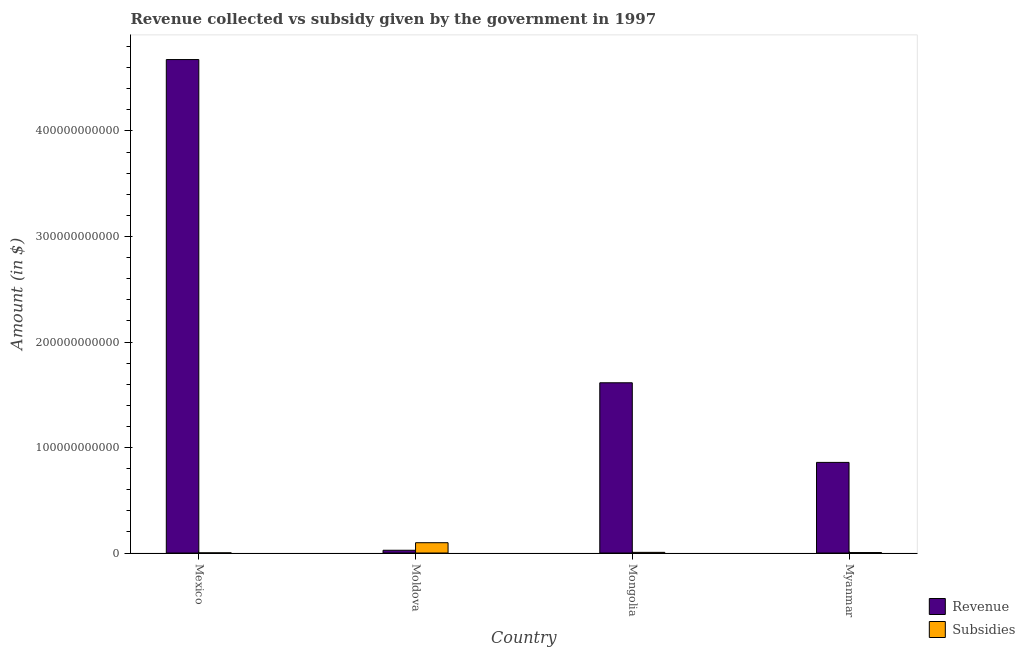How many different coloured bars are there?
Keep it short and to the point. 2. Are the number of bars per tick equal to the number of legend labels?
Ensure brevity in your answer.  Yes. Are the number of bars on each tick of the X-axis equal?
Your answer should be very brief. Yes. How many bars are there on the 2nd tick from the right?
Your response must be concise. 2. What is the label of the 1st group of bars from the left?
Give a very brief answer. Mexico. In how many cases, is the number of bars for a given country not equal to the number of legend labels?
Provide a short and direct response. 0. What is the amount of subsidies given in Mexico?
Keep it short and to the point. 1.33e+08. Across all countries, what is the maximum amount of subsidies given?
Provide a short and direct response. 9.78e+09. Across all countries, what is the minimum amount of revenue collected?
Your answer should be compact. 2.62e+09. In which country was the amount of subsidies given maximum?
Your response must be concise. Moldova. What is the total amount of revenue collected in the graph?
Make the answer very short. 7.18e+11. What is the difference between the amount of revenue collected in Mongolia and that in Myanmar?
Keep it short and to the point. 7.55e+1. What is the difference between the amount of subsidies given in Mexico and the amount of revenue collected in Mongolia?
Provide a short and direct response. -1.61e+11. What is the average amount of revenue collected per country?
Offer a terse response. 1.79e+11. What is the difference between the amount of subsidies given and amount of revenue collected in Mongolia?
Offer a terse response. -1.61e+11. In how many countries, is the amount of revenue collected greater than 360000000000 $?
Provide a succinct answer. 1. What is the ratio of the amount of revenue collected in Mexico to that in Myanmar?
Keep it short and to the point. 5.45. Is the amount of subsidies given in Moldova less than that in Myanmar?
Your answer should be compact. No. Is the difference between the amount of subsidies given in Moldova and Mongolia greater than the difference between the amount of revenue collected in Moldova and Mongolia?
Ensure brevity in your answer.  Yes. What is the difference between the highest and the second highest amount of revenue collected?
Make the answer very short. 3.06e+11. What is the difference between the highest and the lowest amount of subsidies given?
Offer a terse response. 9.64e+09. In how many countries, is the amount of revenue collected greater than the average amount of revenue collected taken over all countries?
Offer a terse response. 1. Is the sum of the amount of revenue collected in Mexico and Myanmar greater than the maximum amount of subsidies given across all countries?
Ensure brevity in your answer.  Yes. What does the 1st bar from the left in Mexico represents?
Keep it short and to the point. Revenue. What does the 2nd bar from the right in Myanmar represents?
Keep it short and to the point. Revenue. Are all the bars in the graph horizontal?
Your answer should be very brief. No. What is the difference between two consecutive major ticks on the Y-axis?
Provide a short and direct response. 1.00e+11. Are the values on the major ticks of Y-axis written in scientific E-notation?
Offer a very short reply. No. Does the graph contain any zero values?
Give a very brief answer. No. Where does the legend appear in the graph?
Offer a terse response. Bottom right. How many legend labels are there?
Give a very brief answer. 2. What is the title of the graph?
Provide a succinct answer. Revenue collected vs subsidy given by the government in 1997. Does "Highest 10% of population" appear as one of the legend labels in the graph?
Your answer should be very brief. No. What is the label or title of the Y-axis?
Offer a very short reply. Amount (in $). What is the Amount (in $) in Revenue in Mexico?
Your response must be concise. 4.68e+11. What is the Amount (in $) in Subsidies in Mexico?
Offer a very short reply. 1.33e+08. What is the Amount (in $) in Revenue in Moldova?
Your answer should be compact. 2.62e+09. What is the Amount (in $) of Subsidies in Moldova?
Offer a terse response. 9.78e+09. What is the Amount (in $) of Revenue in Mongolia?
Offer a very short reply. 1.61e+11. What is the Amount (in $) in Subsidies in Mongolia?
Your answer should be compact. 6.39e+08. What is the Amount (in $) of Revenue in Myanmar?
Offer a very short reply. 8.59e+1. What is the Amount (in $) of Subsidies in Myanmar?
Your answer should be very brief. 4.36e+08. Across all countries, what is the maximum Amount (in $) of Revenue?
Your answer should be very brief. 4.68e+11. Across all countries, what is the maximum Amount (in $) of Subsidies?
Your answer should be very brief. 9.78e+09. Across all countries, what is the minimum Amount (in $) of Revenue?
Ensure brevity in your answer.  2.62e+09. Across all countries, what is the minimum Amount (in $) in Subsidies?
Your answer should be very brief. 1.33e+08. What is the total Amount (in $) of Revenue in the graph?
Offer a terse response. 7.18e+11. What is the total Amount (in $) in Subsidies in the graph?
Your answer should be very brief. 1.10e+1. What is the difference between the Amount (in $) in Revenue in Mexico and that in Moldova?
Offer a terse response. 4.65e+11. What is the difference between the Amount (in $) of Subsidies in Mexico and that in Moldova?
Ensure brevity in your answer.  -9.64e+09. What is the difference between the Amount (in $) in Revenue in Mexico and that in Mongolia?
Give a very brief answer. 3.06e+11. What is the difference between the Amount (in $) in Subsidies in Mexico and that in Mongolia?
Your response must be concise. -5.06e+08. What is the difference between the Amount (in $) of Revenue in Mexico and that in Myanmar?
Your answer should be very brief. 3.82e+11. What is the difference between the Amount (in $) in Subsidies in Mexico and that in Myanmar?
Provide a succinct answer. -3.03e+08. What is the difference between the Amount (in $) of Revenue in Moldova and that in Mongolia?
Offer a terse response. -1.59e+11. What is the difference between the Amount (in $) of Subsidies in Moldova and that in Mongolia?
Offer a very short reply. 9.14e+09. What is the difference between the Amount (in $) of Revenue in Moldova and that in Myanmar?
Ensure brevity in your answer.  -8.33e+1. What is the difference between the Amount (in $) of Subsidies in Moldova and that in Myanmar?
Offer a terse response. 9.34e+09. What is the difference between the Amount (in $) of Revenue in Mongolia and that in Myanmar?
Keep it short and to the point. 7.55e+1. What is the difference between the Amount (in $) of Subsidies in Mongolia and that in Myanmar?
Give a very brief answer. 2.03e+08. What is the difference between the Amount (in $) in Revenue in Mexico and the Amount (in $) in Subsidies in Moldova?
Provide a short and direct response. 4.58e+11. What is the difference between the Amount (in $) of Revenue in Mexico and the Amount (in $) of Subsidies in Mongolia?
Provide a succinct answer. 4.67e+11. What is the difference between the Amount (in $) in Revenue in Mexico and the Amount (in $) in Subsidies in Myanmar?
Your response must be concise. 4.67e+11. What is the difference between the Amount (in $) in Revenue in Moldova and the Amount (in $) in Subsidies in Mongolia?
Make the answer very short. 1.98e+09. What is the difference between the Amount (in $) of Revenue in Moldova and the Amount (in $) of Subsidies in Myanmar?
Your answer should be compact. 2.19e+09. What is the difference between the Amount (in $) of Revenue in Mongolia and the Amount (in $) of Subsidies in Myanmar?
Make the answer very short. 1.61e+11. What is the average Amount (in $) of Revenue per country?
Your answer should be compact. 1.79e+11. What is the average Amount (in $) in Subsidies per country?
Keep it short and to the point. 2.75e+09. What is the difference between the Amount (in $) in Revenue and Amount (in $) in Subsidies in Mexico?
Give a very brief answer. 4.68e+11. What is the difference between the Amount (in $) in Revenue and Amount (in $) in Subsidies in Moldova?
Offer a terse response. -7.16e+09. What is the difference between the Amount (in $) in Revenue and Amount (in $) in Subsidies in Mongolia?
Offer a very short reply. 1.61e+11. What is the difference between the Amount (in $) in Revenue and Amount (in $) in Subsidies in Myanmar?
Keep it short and to the point. 8.55e+1. What is the ratio of the Amount (in $) in Revenue in Mexico to that in Moldova?
Offer a terse response. 178.4. What is the ratio of the Amount (in $) in Subsidies in Mexico to that in Moldova?
Your response must be concise. 0.01. What is the ratio of the Amount (in $) of Revenue in Mexico to that in Mongolia?
Offer a terse response. 2.9. What is the ratio of the Amount (in $) of Subsidies in Mexico to that in Mongolia?
Provide a succinct answer. 0.21. What is the ratio of the Amount (in $) in Revenue in Mexico to that in Myanmar?
Keep it short and to the point. 5.45. What is the ratio of the Amount (in $) of Subsidies in Mexico to that in Myanmar?
Your response must be concise. 0.3. What is the ratio of the Amount (in $) in Revenue in Moldova to that in Mongolia?
Offer a terse response. 0.02. What is the ratio of the Amount (in $) of Subsidies in Moldova to that in Mongolia?
Give a very brief answer. 15.3. What is the ratio of the Amount (in $) of Revenue in Moldova to that in Myanmar?
Offer a very short reply. 0.03. What is the ratio of the Amount (in $) of Subsidies in Moldova to that in Myanmar?
Your answer should be compact. 22.4. What is the ratio of the Amount (in $) in Revenue in Mongolia to that in Myanmar?
Provide a short and direct response. 1.88. What is the ratio of the Amount (in $) of Subsidies in Mongolia to that in Myanmar?
Provide a short and direct response. 1.46. What is the difference between the highest and the second highest Amount (in $) in Revenue?
Make the answer very short. 3.06e+11. What is the difference between the highest and the second highest Amount (in $) of Subsidies?
Offer a terse response. 9.14e+09. What is the difference between the highest and the lowest Amount (in $) of Revenue?
Provide a succinct answer. 4.65e+11. What is the difference between the highest and the lowest Amount (in $) in Subsidies?
Give a very brief answer. 9.64e+09. 